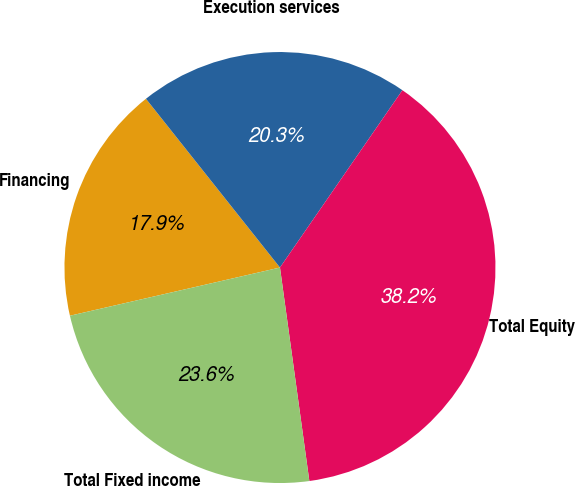Convert chart. <chart><loc_0><loc_0><loc_500><loc_500><pie_chart><fcel>Financing<fcel>Execution services<fcel>Total Equity<fcel>Total Fixed income<nl><fcel>17.91%<fcel>20.3%<fcel>38.21%<fcel>23.59%<nl></chart> 